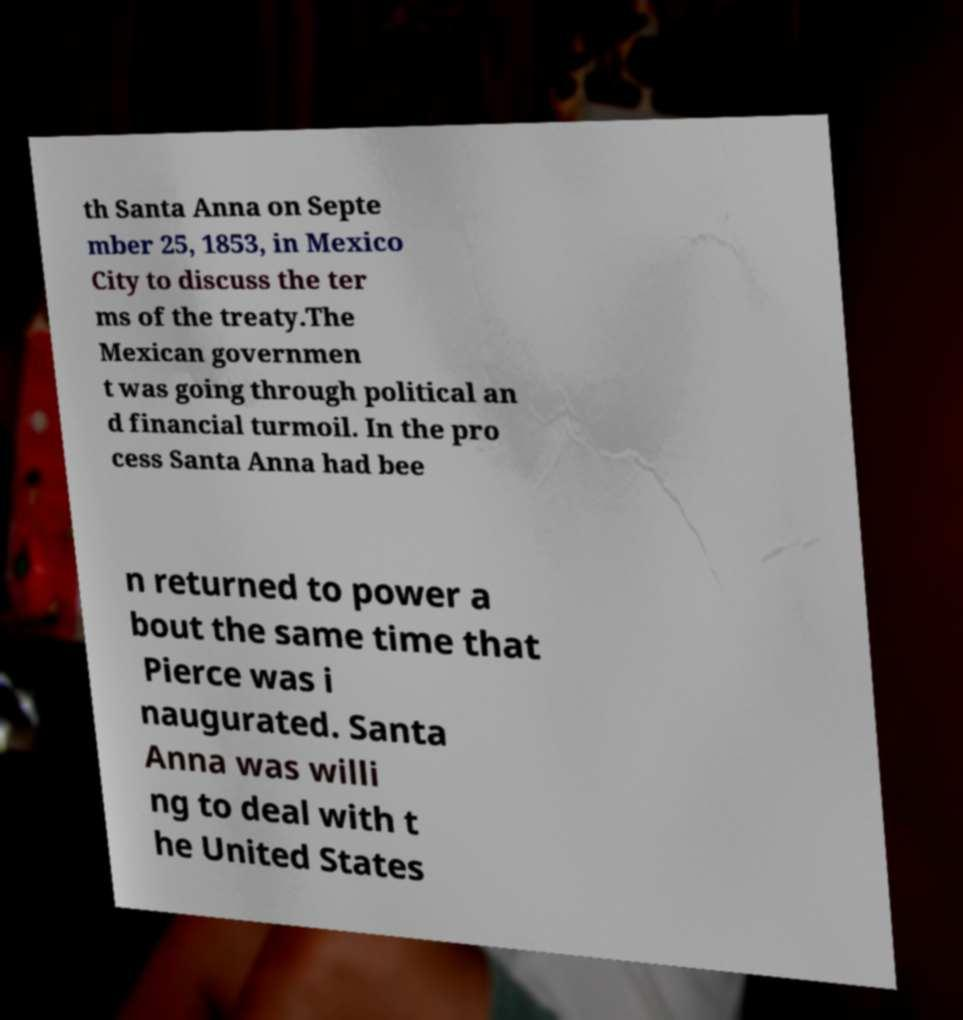For documentation purposes, I need the text within this image transcribed. Could you provide that? th Santa Anna on Septe mber 25, 1853, in Mexico City to discuss the ter ms of the treaty.The Mexican governmen t was going through political an d financial turmoil. In the pro cess Santa Anna had bee n returned to power a bout the same time that Pierce was i naugurated. Santa Anna was willi ng to deal with t he United States 